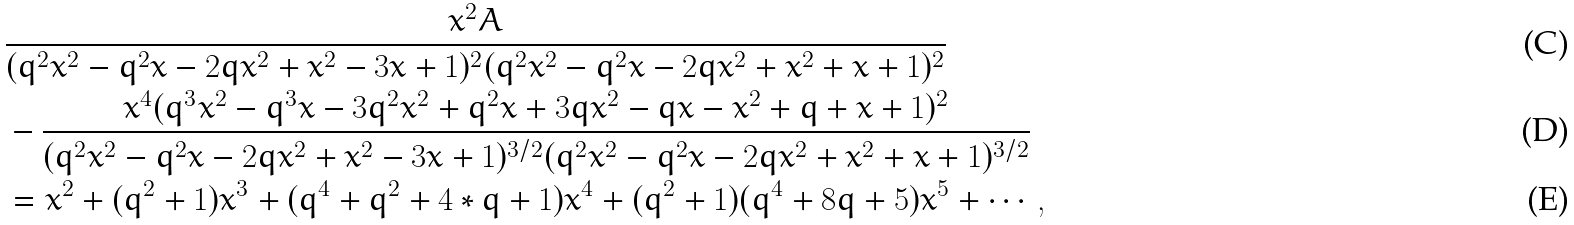Convert formula to latex. <formula><loc_0><loc_0><loc_500><loc_500>& \frac { x ^ { 2 } A } { ( q ^ { 2 } x ^ { 2 } - q ^ { 2 } x - 2 q x ^ { 2 } + x ^ { 2 } - 3 x + 1 ) ^ { 2 } ( q ^ { 2 } x ^ { 2 } - q ^ { 2 } x - 2 q x ^ { 2 } + x ^ { 2 } + x + 1 ) ^ { 2 } } \\ & - \frac { x ^ { 4 } ( q ^ { 3 } x ^ { 2 } - q ^ { 3 } x - 3 q ^ { 2 } x ^ { 2 } + q ^ { 2 } x + 3 q x ^ { 2 } - q x - x ^ { 2 } + q + x + 1 ) ^ { 2 } } { ( q ^ { 2 } x ^ { 2 } - q ^ { 2 } x - 2 q x ^ { 2 } + x ^ { 2 } - 3 x + 1 ) ^ { 3 / 2 } ( q ^ { 2 } x ^ { 2 } - q ^ { 2 } x - 2 q x ^ { 2 } + x ^ { 2 } + x + 1 ) ^ { 3 / 2 } } \\ & = x ^ { 2 } + ( q ^ { 2 } + 1 ) x ^ { 3 } + ( q ^ { 4 } + q ^ { 2 } + 4 * q + 1 ) x ^ { 4 } + ( q ^ { 2 } + 1 ) ( q ^ { 4 } + 8 q + 5 ) x ^ { 5 } + \cdots ,</formula> 